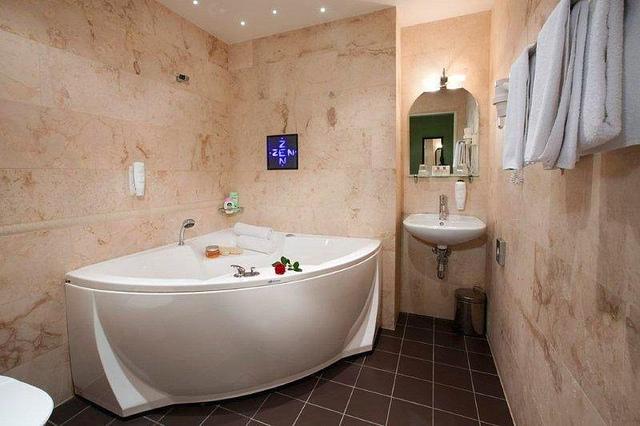Is there sunlight coming in?
Be succinct. No. What color is the towel closest to the tub?
Be succinct. White. Is a shower shown?
Write a very short answer. No. What does the pink paint look like on the wall?
Answer briefly. Marble. What room is this?
Quick response, please. Bathroom. What color is the rose laying on the tub?
Keep it brief. Red. 